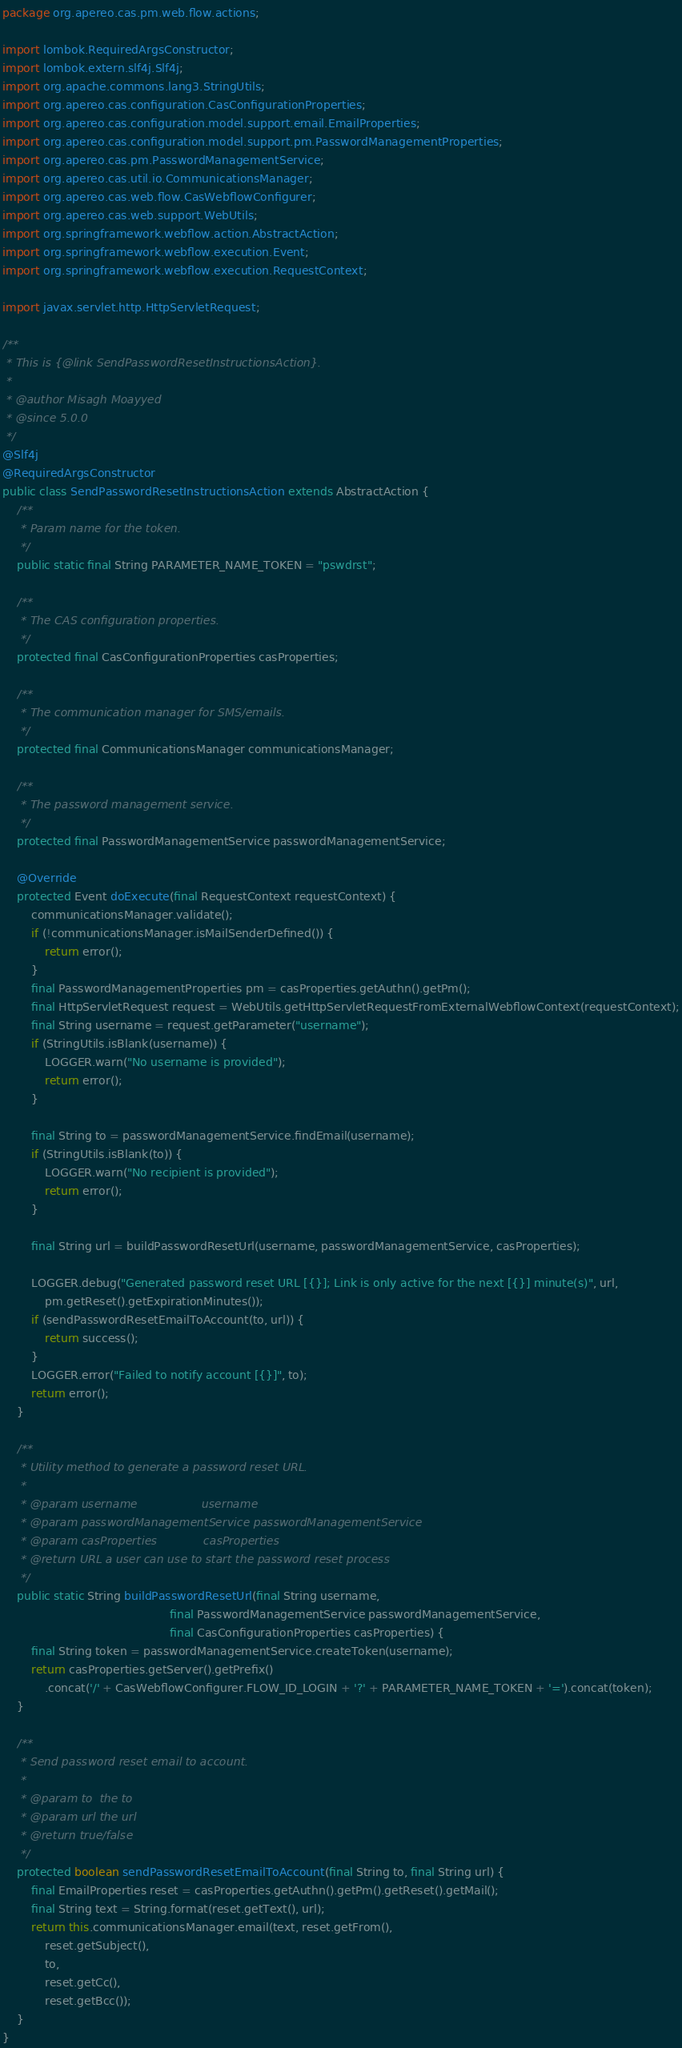Convert code to text. <code><loc_0><loc_0><loc_500><loc_500><_Java_>package org.apereo.cas.pm.web.flow.actions;

import lombok.RequiredArgsConstructor;
import lombok.extern.slf4j.Slf4j;
import org.apache.commons.lang3.StringUtils;
import org.apereo.cas.configuration.CasConfigurationProperties;
import org.apereo.cas.configuration.model.support.email.EmailProperties;
import org.apereo.cas.configuration.model.support.pm.PasswordManagementProperties;
import org.apereo.cas.pm.PasswordManagementService;
import org.apereo.cas.util.io.CommunicationsManager;
import org.apereo.cas.web.flow.CasWebflowConfigurer;
import org.apereo.cas.web.support.WebUtils;
import org.springframework.webflow.action.AbstractAction;
import org.springframework.webflow.execution.Event;
import org.springframework.webflow.execution.RequestContext;

import javax.servlet.http.HttpServletRequest;

/**
 * This is {@link SendPasswordResetInstructionsAction}.
 *
 * @author Misagh Moayyed
 * @since 5.0.0
 */
@Slf4j
@RequiredArgsConstructor
public class SendPasswordResetInstructionsAction extends AbstractAction {
    /**
     * Param name for the token.
     */
    public static final String PARAMETER_NAME_TOKEN = "pswdrst";

    /**
     * The CAS configuration properties.
     */
    protected final CasConfigurationProperties casProperties;

    /**
     * The communication manager for SMS/emails.
     */
    protected final CommunicationsManager communicationsManager;

    /**
     * The password management service.
     */
    protected final PasswordManagementService passwordManagementService;

    @Override
    protected Event doExecute(final RequestContext requestContext) {
        communicationsManager.validate();
        if (!communicationsManager.isMailSenderDefined()) {
            return error();
        }
        final PasswordManagementProperties pm = casProperties.getAuthn().getPm();
        final HttpServletRequest request = WebUtils.getHttpServletRequestFromExternalWebflowContext(requestContext);
        final String username = request.getParameter("username");
        if (StringUtils.isBlank(username)) {
            LOGGER.warn("No username is provided");
            return error();
        }

        final String to = passwordManagementService.findEmail(username);
        if (StringUtils.isBlank(to)) {
            LOGGER.warn("No recipient is provided");
            return error();
        }

        final String url = buildPasswordResetUrl(username, passwordManagementService, casProperties);

        LOGGER.debug("Generated password reset URL [{}]; Link is only active for the next [{}] minute(s)", url,
            pm.getReset().getExpirationMinutes());
        if (sendPasswordResetEmailToAccount(to, url)) {
            return success();
        }
        LOGGER.error("Failed to notify account [{}]", to);
        return error();
    }

    /**
     * Utility method to generate a password reset URL.
     *
     * @param username                  username
     * @param passwordManagementService passwordManagementService
     * @param casProperties             casProperties
     * @return URL a user can use to start the password reset process
     */
    public static String buildPasswordResetUrl(final String username,
                                               final PasswordManagementService passwordManagementService,
                                               final CasConfigurationProperties casProperties) {
        final String token = passwordManagementService.createToken(username);
        return casProperties.getServer().getPrefix()
            .concat('/' + CasWebflowConfigurer.FLOW_ID_LOGIN + '?' + PARAMETER_NAME_TOKEN + '=').concat(token);
    }

    /**
     * Send password reset email to account.
     *
     * @param to  the to
     * @param url the url
     * @return true/false
     */
    protected boolean sendPasswordResetEmailToAccount(final String to, final String url) {
        final EmailProperties reset = casProperties.getAuthn().getPm().getReset().getMail();
        final String text = String.format(reset.getText(), url);
        return this.communicationsManager.email(text, reset.getFrom(),
            reset.getSubject(),
            to,
            reset.getCc(),
            reset.getBcc());
    }
}
</code> 